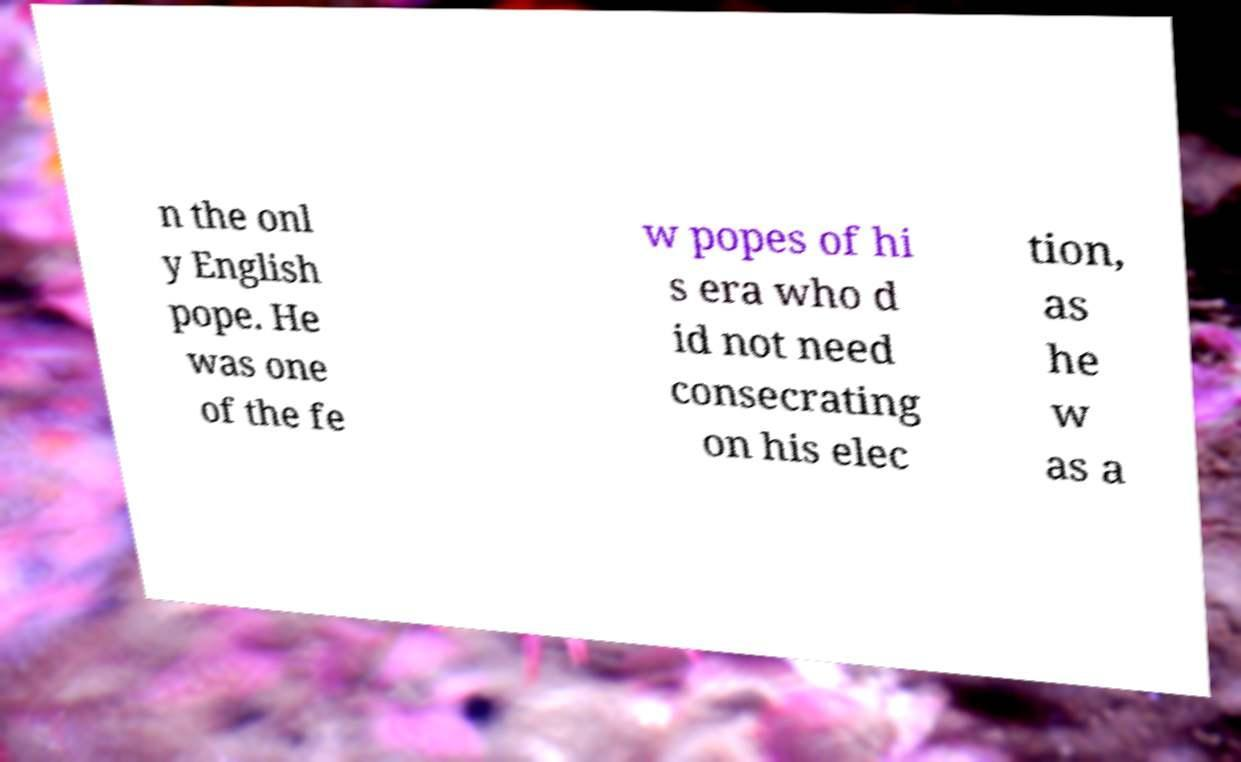Can you read and provide the text displayed in the image?This photo seems to have some interesting text. Can you extract and type it out for me? n the onl y English pope. He was one of the fe w popes of hi s era who d id not need consecrating on his elec tion, as he w as a 